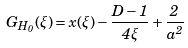Convert formula to latex. <formula><loc_0><loc_0><loc_500><loc_500>G _ { H _ { 0 } } ( \xi ) = x ( \xi ) - \frac { D - 1 } { 4 \xi } + \frac { 2 } { a ^ { 2 } }</formula> 